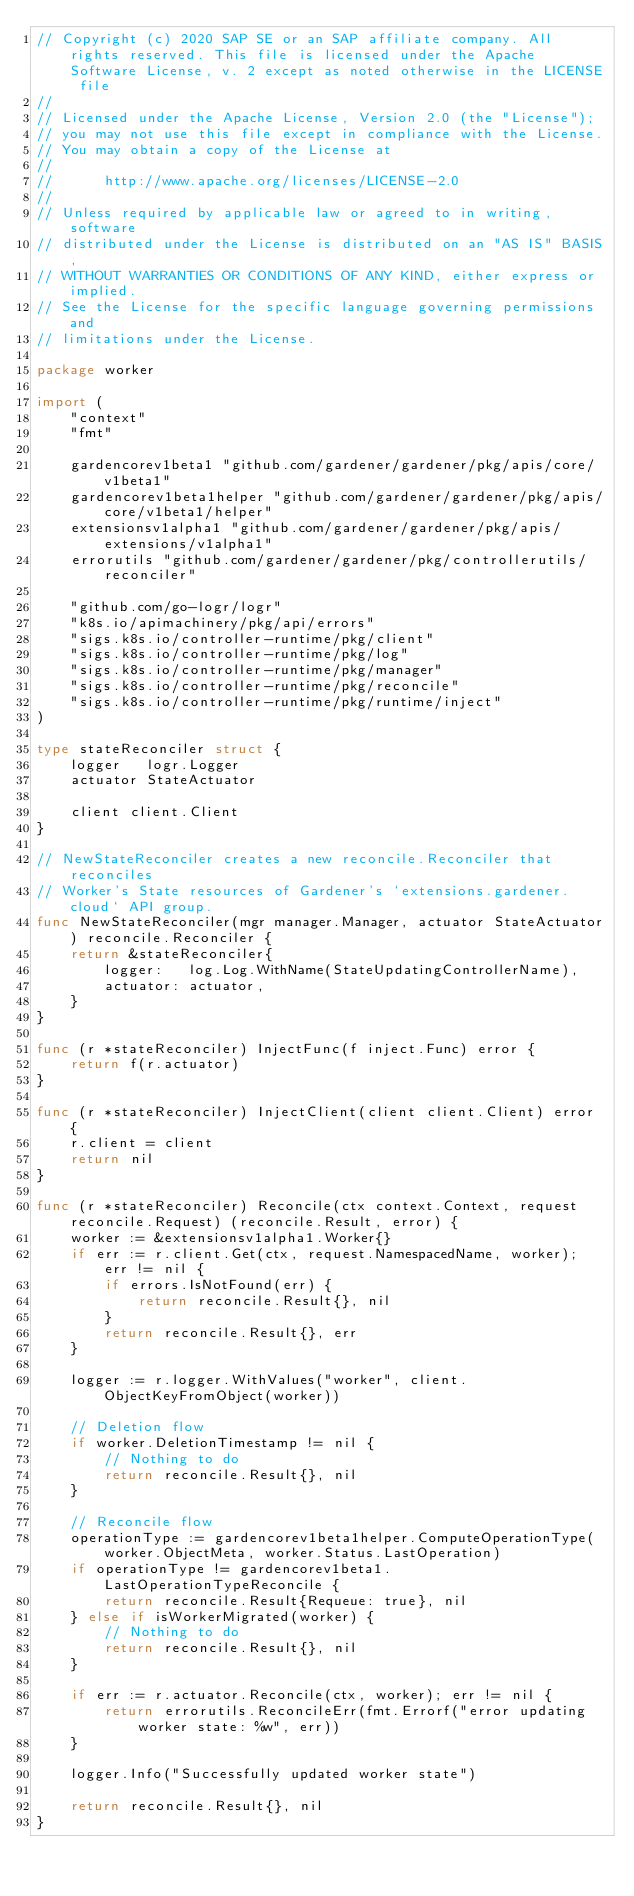<code> <loc_0><loc_0><loc_500><loc_500><_Go_>// Copyright (c) 2020 SAP SE or an SAP affiliate company. All rights reserved. This file is licensed under the Apache Software License, v. 2 except as noted otherwise in the LICENSE file
//
// Licensed under the Apache License, Version 2.0 (the "License");
// you may not use this file except in compliance with the License.
// You may obtain a copy of the License at
//
//      http://www.apache.org/licenses/LICENSE-2.0
//
// Unless required by applicable law or agreed to in writing, software
// distributed under the License is distributed on an "AS IS" BASIS,
// WITHOUT WARRANTIES OR CONDITIONS OF ANY KIND, either express or implied.
// See the License for the specific language governing permissions and
// limitations under the License.

package worker

import (
	"context"
	"fmt"

	gardencorev1beta1 "github.com/gardener/gardener/pkg/apis/core/v1beta1"
	gardencorev1beta1helper "github.com/gardener/gardener/pkg/apis/core/v1beta1/helper"
	extensionsv1alpha1 "github.com/gardener/gardener/pkg/apis/extensions/v1alpha1"
	errorutils "github.com/gardener/gardener/pkg/controllerutils/reconciler"

	"github.com/go-logr/logr"
	"k8s.io/apimachinery/pkg/api/errors"
	"sigs.k8s.io/controller-runtime/pkg/client"
	"sigs.k8s.io/controller-runtime/pkg/log"
	"sigs.k8s.io/controller-runtime/pkg/manager"
	"sigs.k8s.io/controller-runtime/pkg/reconcile"
	"sigs.k8s.io/controller-runtime/pkg/runtime/inject"
)

type stateReconciler struct {
	logger   logr.Logger
	actuator StateActuator

	client client.Client
}

// NewStateReconciler creates a new reconcile.Reconciler that reconciles
// Worker's State resources of Gardener's `extensions.gardener.cloud` API group.
func NewStateReconciler(mgr manager.Manager, actuator StateActuator) reconcile.Reconciler {
	return &stateReconciler{
		logger:   log.Log.WithName(StateUpdatingControllerName),
		actuator: actuator,
	}
}

func (r *stateReconciler) InjectFunc(f inject.Func) error {
	return f(r.actuator)
}

func (r *stateReconciler) InjectClient(client client.Client) error {
	r.client = client
	return nil
}

func (r *stateReconciler) Reconcile(ctx context.Context, request reconcile.Request) (reconcile.Result, error) {
	worker := &extensionsv1alpha1.Worker{}
	if err := r.client.Get(ctx, request.NamespacedName, worker); err != nil {
		if errors.IsNotFound(err) {
			return reconcile.Result{}, nil
		}
		return reconcile.Result{}, err
	}

	logger := r.logger.WithValues("worker", client.ObjectKeyFromObject(worker))

	// Deletion flow
	if worker.DeletionTimestamp != nil {
		// Nothing to do
		return reconcile.Result{}, nil
	}

	// Reconcile flow
	operationType := gardencorev1beta1helper.ComputeOperationType(worker.ObjectMeta, worker.Status.LastOperation)
	if operationType != gardencorev1beta1.LastOperationTypeReconcile {
		return reconcile.Result{Requeue: true}, nil
	} else if isWorkerMigrated(worker) {
		// Nothing to do
		return reconcile.Result{}, nil
	}

	if err := r.actuator.Reconcile(ctx, worker); err != nil {
		return errorutils.ReconcileErr(fmt.Errorf("error updating worker state: %w", err))
	}

	logger.Info("Successfully updated worker state")

	return reconcile.Result{}, nil
}
</code> 